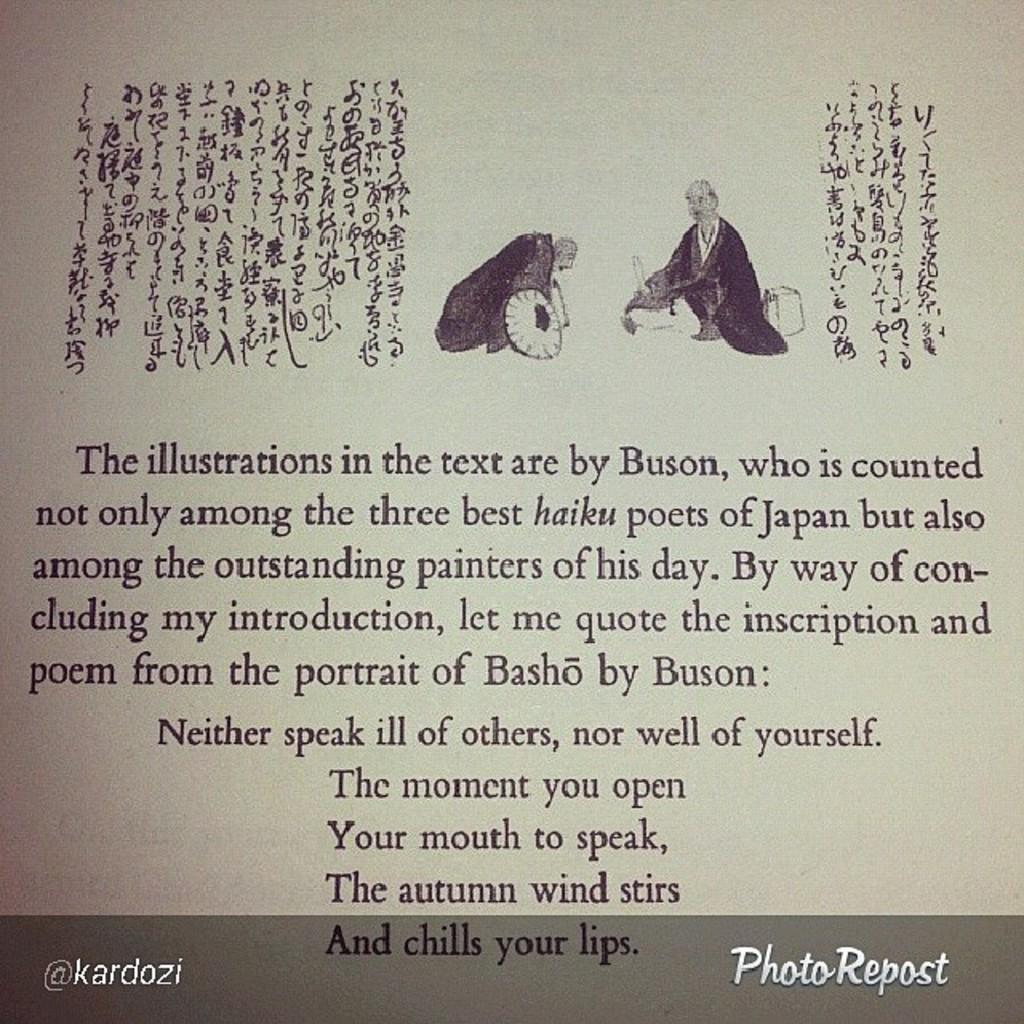<image>
Describe the image concisely. A page about a book's illustrations has the Twitter username @kardozi on it. 